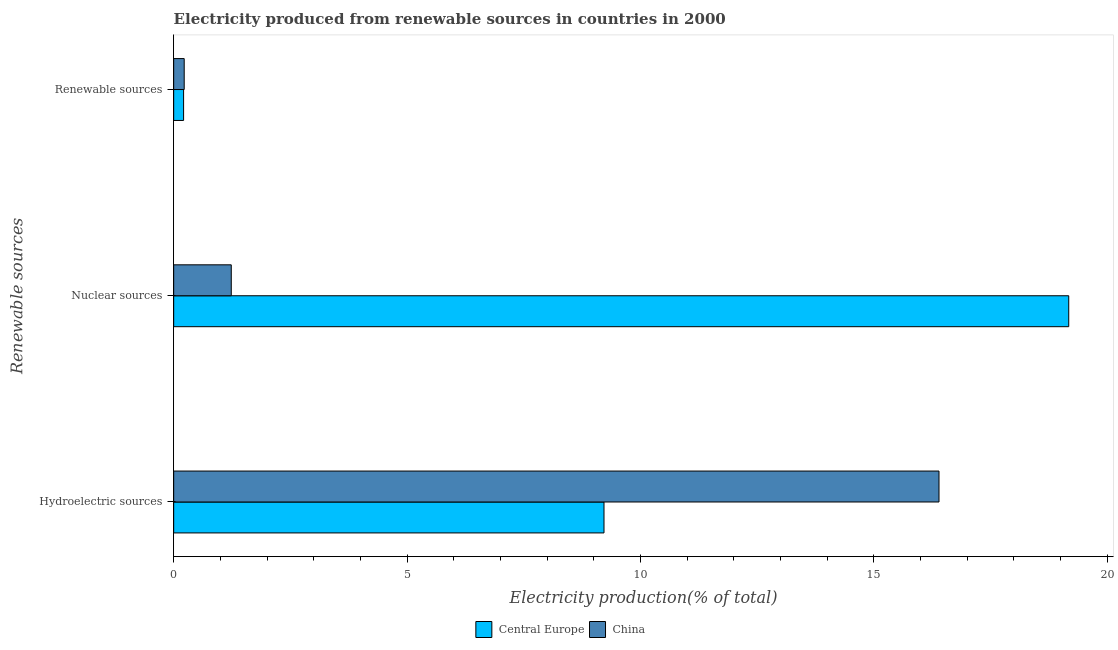How many different coloured bars are there?
Your answer should be compact. 2. Are the number of bars on each tick of the Y-axis equal?
Your answer should be compact. Yes. How many bars are there on the 3rd tick from the top?
Make the answer very short. 2. What is the label of the 1st group of bars from the top?
Provide a succinct answer. Renewable sources. What is the percentage of electricity produced by hydroelectric sources in Central Europe?
Make the answer very short. 9.22. Across all countries, what is the maximum percentage of electricity produced by nuclear sources?
Make the answer very short. 19.18. Across all countries, what is the minimum percentage of electricity produced by nuclear sources?
Ensure brevity in your answer.  1.23. In which country was the percentage of electricity produced by renewable sources maximum?
Your answer should be very brief. China. What is the total percentage of electricity produced by nuclear sources in the graph?
Provide a succinct answer. 20.41. What is the difference between the percentage of electricity produced by renewable sources in China and that in Central Europe?
Offer a terse response. 0.01. What is the difference between the percentage of electricity produced by renewable sources in China and the percentage of electricity produced by nuclear sources in Central Europe?
Offer a very short reply. -18.95. What is the average percentage of electricity produced by nuclear sources per country?
Provide a short and direct response. 10.21. What is the difference between the percentage of electricity produced by hydroelectric sources and percentage of electricity produced by renewable sources in Central Europe?
Provide a succinct answer. 9.01. In how many countries, is the percentage of electricity produced by nuclear sources greater than 1 %?
Provide a short and direct response. 2. What is the ratio of the percentage of electricity produced by hydroelectric sources in China to that in Central Europe?
Provide a short and direct response. 1.78. Is the percentage of electricity produced by renewable sources in Central Europe less than that in China?
Offer a very short reply. Yes. Is the difference between the percentage of electricity produced by hydroelectric sources in Central Europe and China greater than the difference between the percentage of electricity produced by renewable sources in Central Europe and China?
Your answer should be compact. No. What is the difference between the highest and the second highest percentage of electricity produced by hydroelectric sources?
Keep it short and to the point. 7.18. What is the difference between the highest and the lowest percentage of electricity produced by hydroelectric sources?
Keep it short and to the point. 7.18. In how many countries, is the percentage of electricity produced by hydroelectric sources greater than the average percentage of electricity produced by hydroelectric sources taken over all countries?
Give a very brief answer. 1. What does the 2nd bar from the top in Renewable sources represents?
Give a very brief answer. Central Europe. What does the 2nd bar from the bottom in Hydroelectric sources represents?
Keep it short and to the point. China. Are all the bars in the graph horizontal?
Provide a succinct answer. Yes. What is the difference between two consecutive major ticks on the X-axis?
Give a very brief answer. 5. Are the values on the major ticks of X-axis written in scientific E-notation?
Your answer should be compact. No. Does the graph contain any zero values?
Your answer should be very brief. No. What is the title of the graph?
Ensure brevity in your answer.  Electricity produced from renewable sources in countries in 2000. Does "Virgin Islands" appear as one of the legend labels in the graph?
Your response must be concise. No. What is the label or title of the X-axis?
Keep it short and to the point. Electricity production(% of total). What is the label or title of the Y-axis?
Provide a succinct answer. Renewable sources. What is the Electricity production(% of total) of Central Europe in Hydroelectric sources?
Give a very brief answer. 9.22. What is the Electricity production(% of total) in China in Hydroelectric sources?
Make the answer very short. 16.4. What is the Electricity production(% of total) of Central Europe in Nuclear sources?
Your answer should be very brief. 19.18. What is the Electricity production(% of total) in China in Nuclear sources?
Provide a succinct answer. 1.23. What is the Electricity production(% of total) in Central Europe in Renewable sources?
Your response must be concise. 0.21. What is the Electricity production(% of total) in China in Renewable sources?
Your answer should be compact. 0.23. Across all Renewable sources, what is the maximum Electricity production(% of total) of Central Europe?
Your answer should be compact. 19.18. Across all Renewable sources, what is the maximum Electricity production(% of total) in China?
Make the answer very short. 16.4. Across all Renewable sources, what is the minimum Electricity production(% of total) in Central Europe?
Your answer should be very brief. 0.21. Across all Renewable sources, what is the minimum Electricity production(% of total) in China?
Your answer should be very brief. 0.23. What is the total Electricity production(% of total) of Central Europe in the graph?
Provide a succinct answer. 28.61. What is the total Electricity production(% of total) of China in the graph?
Keep it short and to the point. 17.86. What is the difference between the Electricity production(% of total) of Central Europe in Hydroelectric sources and that in Nuclear sources?
Keep it short and to the point. -9.96. What is the difference between the Electricity production(% of total) of China in Hydroelectric sources and that in Nuclear sources?
Give a very brief answer. 15.17. What is the difference between the Electricity production(% of total) of Central Europe in Hydroelectric sources and that in Renewable sources?
Offer a very short reply. 9.01. What is the difference between the Electricity production(% of total) of China in Hydroelectric sources and that in Renewable sources?
Offer a terse response. 16.17. What is the difference between the Electricity production(% of total) of Central Europe in Nuclear sources and that in Renewable sources?
Keep it short and to the point. 18.97. What is the difference between the Electricity production(% of total) of China in Nuclear sources and that in Renewable sources?
Offer a very short reply. 1.01. What is the difference between the Electricity production(% of total) in Central Europe in Hydroelectric sources and the Electricity production(% of total) in China in Nuclear sources?
Your answer should be very brief. 7.99. What is the difference between the Electricity production(% of total) in Central Europe in Hydroelectric sources and the Electricity production(% of total) in China in Renewable sources?
Your answer should be very brief. 9. What is the difference between the Electricity production(% of total) in Central Europe in Nuclear sources and the Electricity production(% of total) in China in Renewable sources?
Make the answer very short. 18.95. What is the average Electricity production(% of total) of Central Europe per Renewable sources?
Offer a terse response. 9.54. What is the average Electricity production(% of total) of China per Renewable sources?
Ensure brevity in your answer.  5.95. What is the difference between the Electricity production(% of total) in Central Europe and Electricity production(% of total) in China in Hydroelectric sources?
Provide a short and direct response. -7.18. What is the difference between the Electricity production(% of total) of Central Europe and Electricity production(% of total) of China in Nuclear sources?
Your answer should be very brief. 17.95. What is the difference between the Electricity production(% of total) in Central Europe and Electricity production(% of total) in China in Renewable sources?
Provide a short and direct response. -0.01. What is the ratio of the Electricity production(% of total) in Central Europe in Hydroelectric sources to that in Nuclear sources?
Your answer should be compact. 0.48. What is the ratio of the Electricity production(% of total) in China in Hydroelectric sources to that in Nuclear sources?
Keep it short and to the point. 13.29. What is the ratio of the Electricity production(% of total) of Central Europe in Hydroelectric sources to that in Renewable sources?
Make the answer very short. 43.41. What is the ratio of the Electricity production(% of total) of China in Hydroelectric sources to that in Renewable sources?
Keep it short and to the point. 72.73. What is the ratio of the Electricity production(% of total) in Central Europe in Nuclear sources to that in Renewable sources?
Give a very brief answer. 90.29. What is the ratio of the Electricity production(% of total) of China in Nuclear sources to that in Renewable sources?
Your response must be concise. 5.47. What is the difference between the highest and the second highest Electricity production(% of total) of Central Europe?
Offer a very short reply. 9.96. What is the difference between the highest and the second highest Electricity production(% of total) of China?
Offer a very short reply. 15.17. What is the difference between the highest and the lowest Electricity production(% of total) of Central Europe?
Make the answer very short. 18.97. What is the difference between the highest and the lowest Electricity production(% of total) of China?
Offer a terse response. 16.17. 